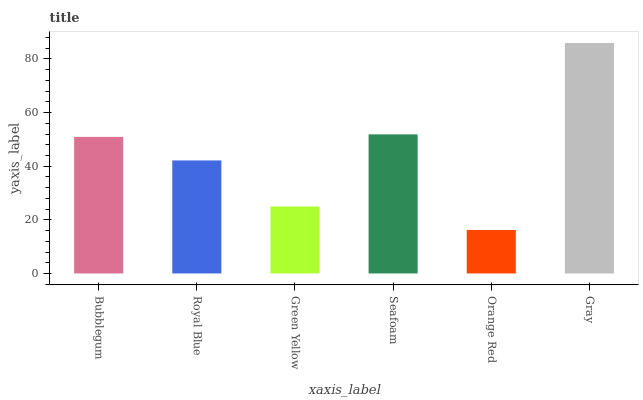Is Orange Red the minimum?
Answer yes or no. Yes. Is Gray the maximum?
Answer yes or no. Yes. Is Royal Blue the minimum?
Answer yes or no. No. Is Royal Blue the maximum?
Answer yes or no. No. Is Bubblegum greater than Royal Blue?
Answer yes or no. Yes. Is Royal Blue less than Bubblegum?
Answer yes or no. Yes. Is Royal Blue greater than Bubblegum?
Answer yes or no. No. Is Bubblegum less than Royal Blue?
Answer yes or no. No. Is Bubblegum the high median?
Answer yes or no. Yes. Is Royal Blue the low median?
Answer yes or no. Yes. Is Gray the high median?
Answer yes or no. No. Is Gray the low median?
Answer yes or no. No. 